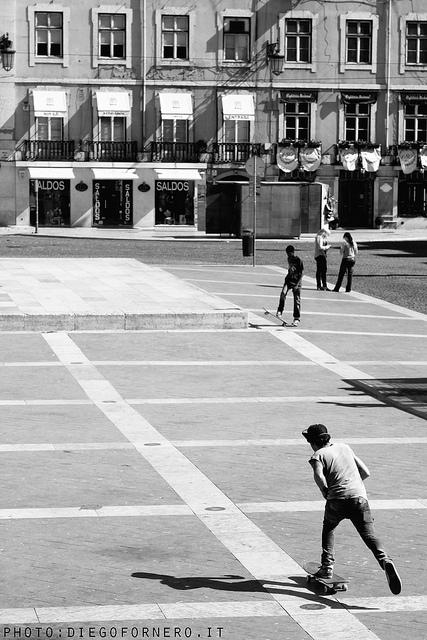Why is the boy kicking his leg back?

Choices:
A) for speed
B) to fight
C) to flip
D) to roll for speed 